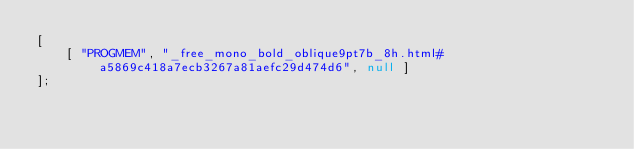<code> <loc_0><loc_0><loc_500><loc_500><_JavaScript_>[
    [ "PROGMEM", "_free_mono_bold_oblique9pt7b_8h.html#a5869c418a7ecb3267a81aefc29d474d6", null ]
];</code> 